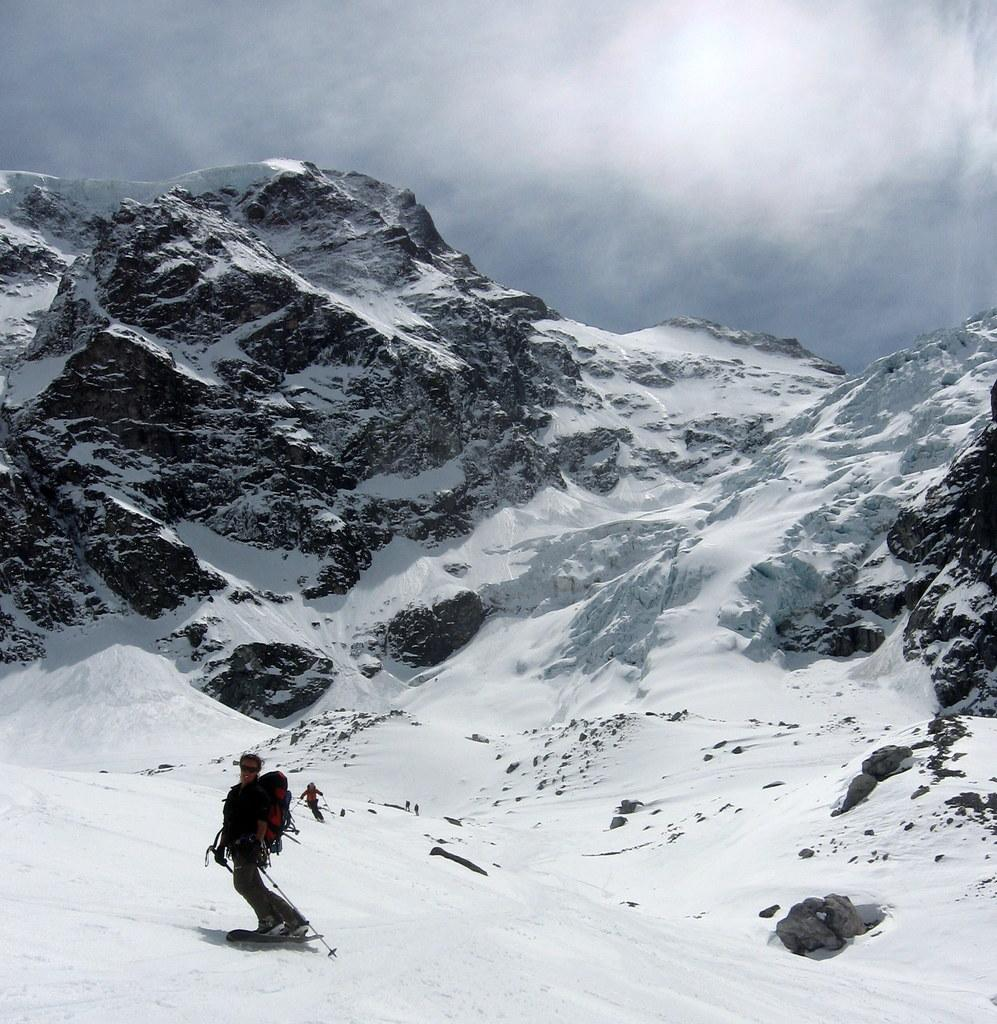What is the main subject of the image? The main subject of the image is ice. What are the people in the image doing? The people in the image are skiing on the ice. What is visible at the top of the image? The sky is visible at the top of the image. What type of spade is being used to attack the skiers in the image? There is no spade or attack present in the image; it features people skiing on ice with the sky visible at the top. 